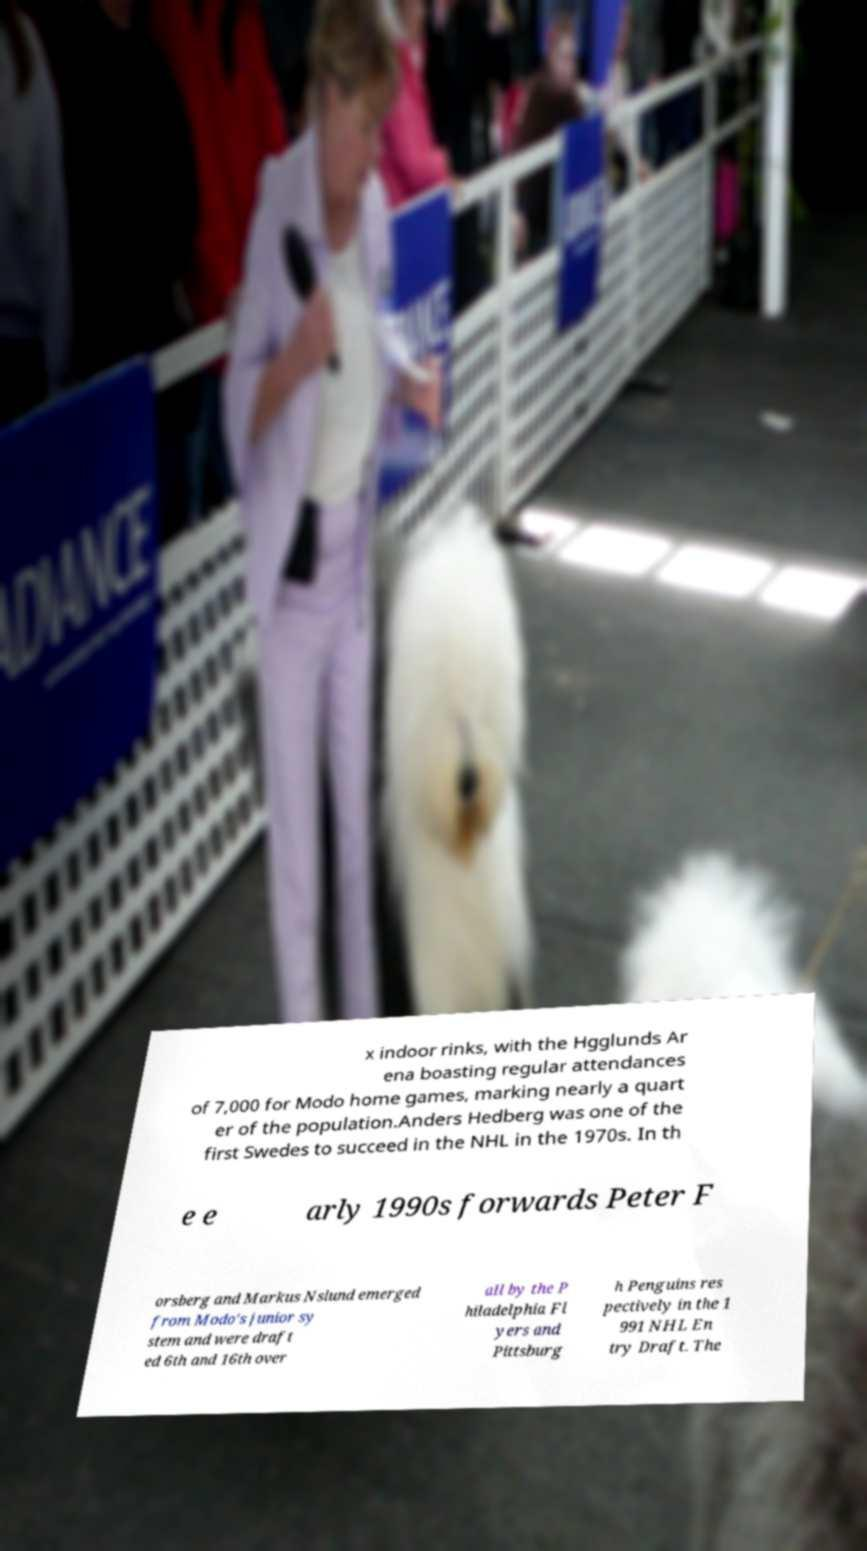Could you assist in decoding the text presented in this image and type it out clearly? x indoor rinks, with the Hgglunds Ar ena boasting regular attendances of 7,000 for Modo home games, marking nearly a quart er of the population.Anders Hedberg was one of the first Swedes to succeed in the NHL in the 1970s. In th e e arly 1990s forwards Peter F orsberg and Markus Nslund emerged from Modo's junior sy stem and were draft ed 6th and 16th over all by the P hiladelphia Fl yers and Pittsburg h Penguins res pectively in the 1 991 NHL En try Draft. The 